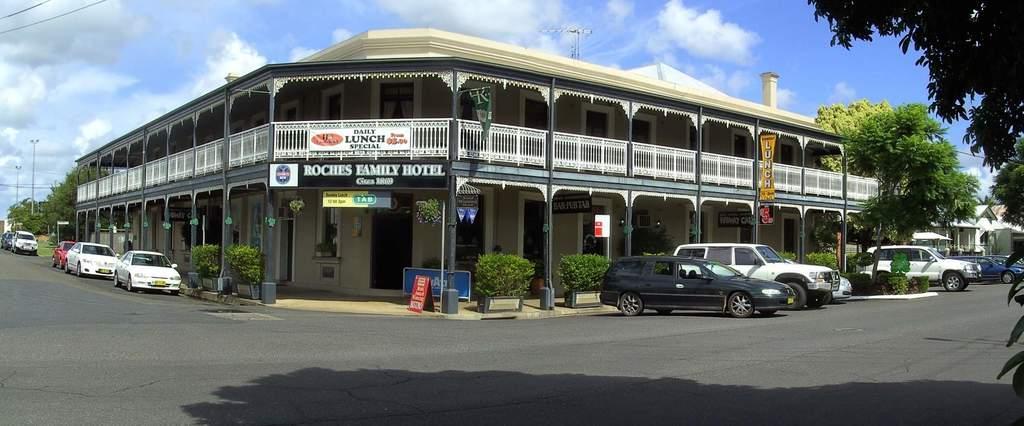How would you summarize this image in a sentence or two? On the right side of the picture there are trees, cars and building. In the center of the picture there are plants, trees, hoardings, towers, cables, building. In the foreground it is road. It is sunny. 